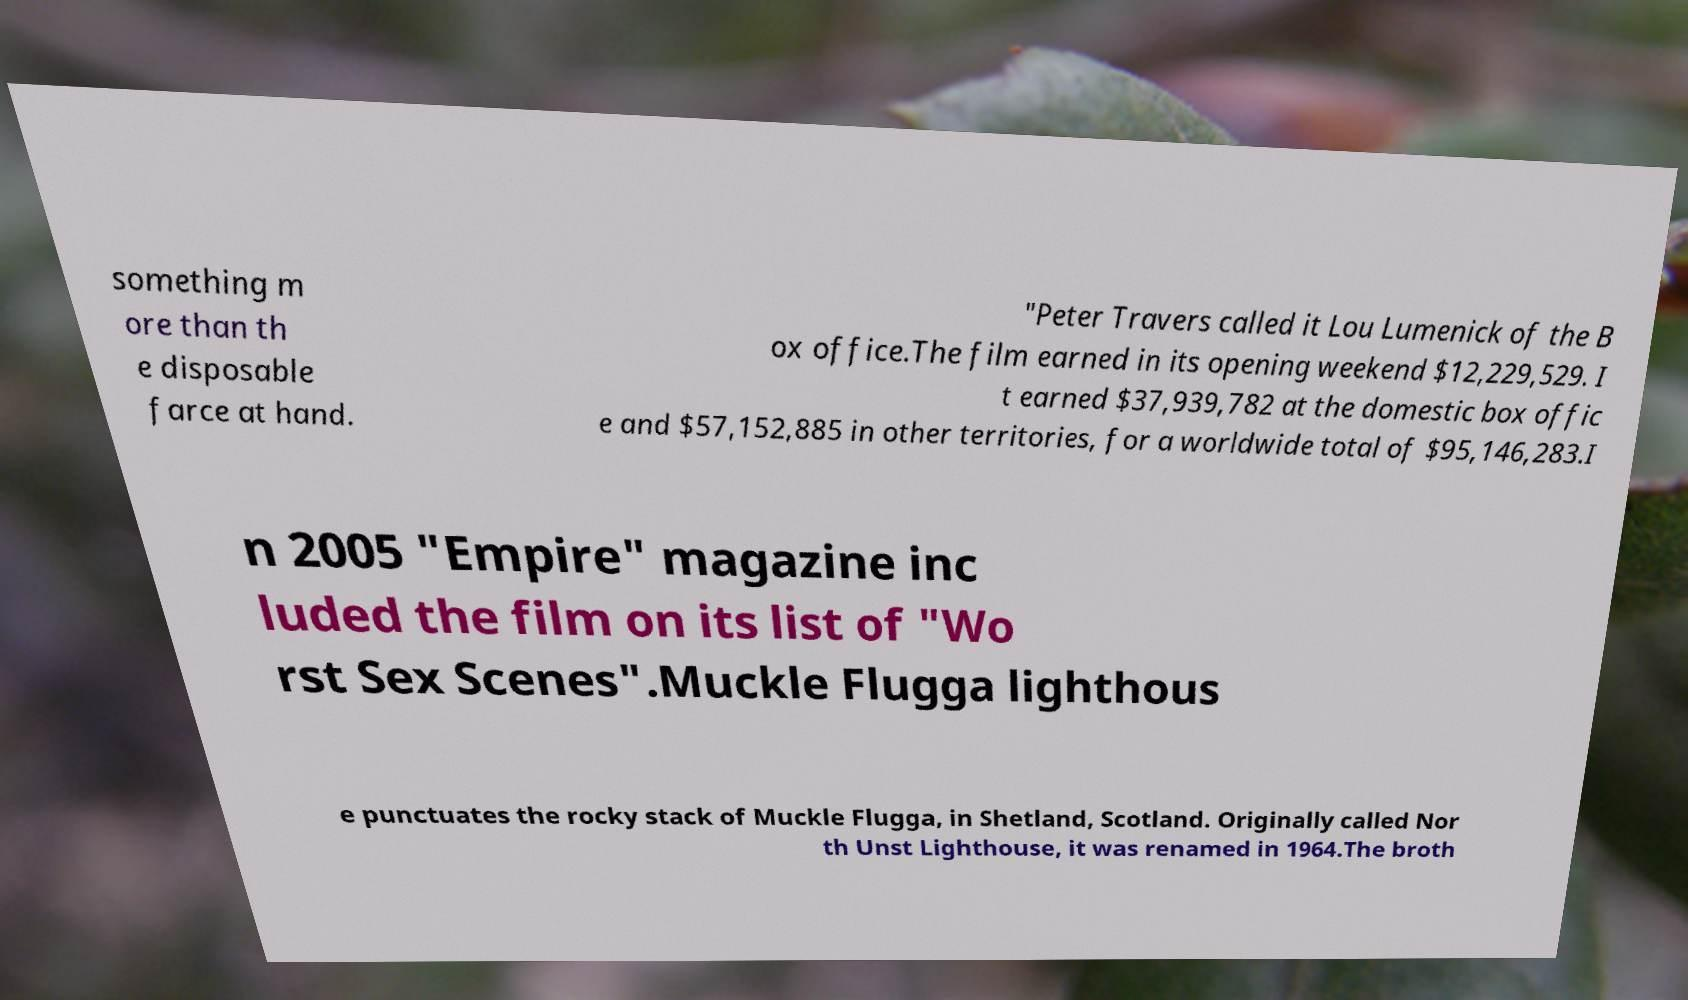Please identify and transcribe the text found in this image. something m ore than th e disposable farce at hand. "Peter Travers called it Lou Lumenick of the B ox office.The film earned in its opening weekend $12,229,529. I t earned $37,939,782 at the domestic box offic e and $57,152,885 in other territories, for a worldwide total of $95,146,283.I n 2005 "Empire" magazine inc luded the film on its list of "Wo rst Sex Scenes".Muckle Flugga lighthous e punctuates the rocky stack of Muckle Flugga, in Shetland, Scotland. Originally called Nor th Unst Lighthouse, it was renamed in 1964.The broth 